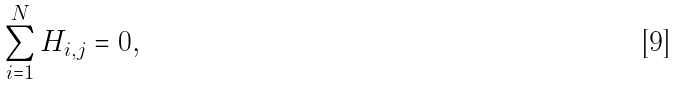<formula> <loc_0><loc_0><loc_500><loc_500>\sum _ { i = 1 } ^ { N } H _ { i , j } = 0 ,</formula> 